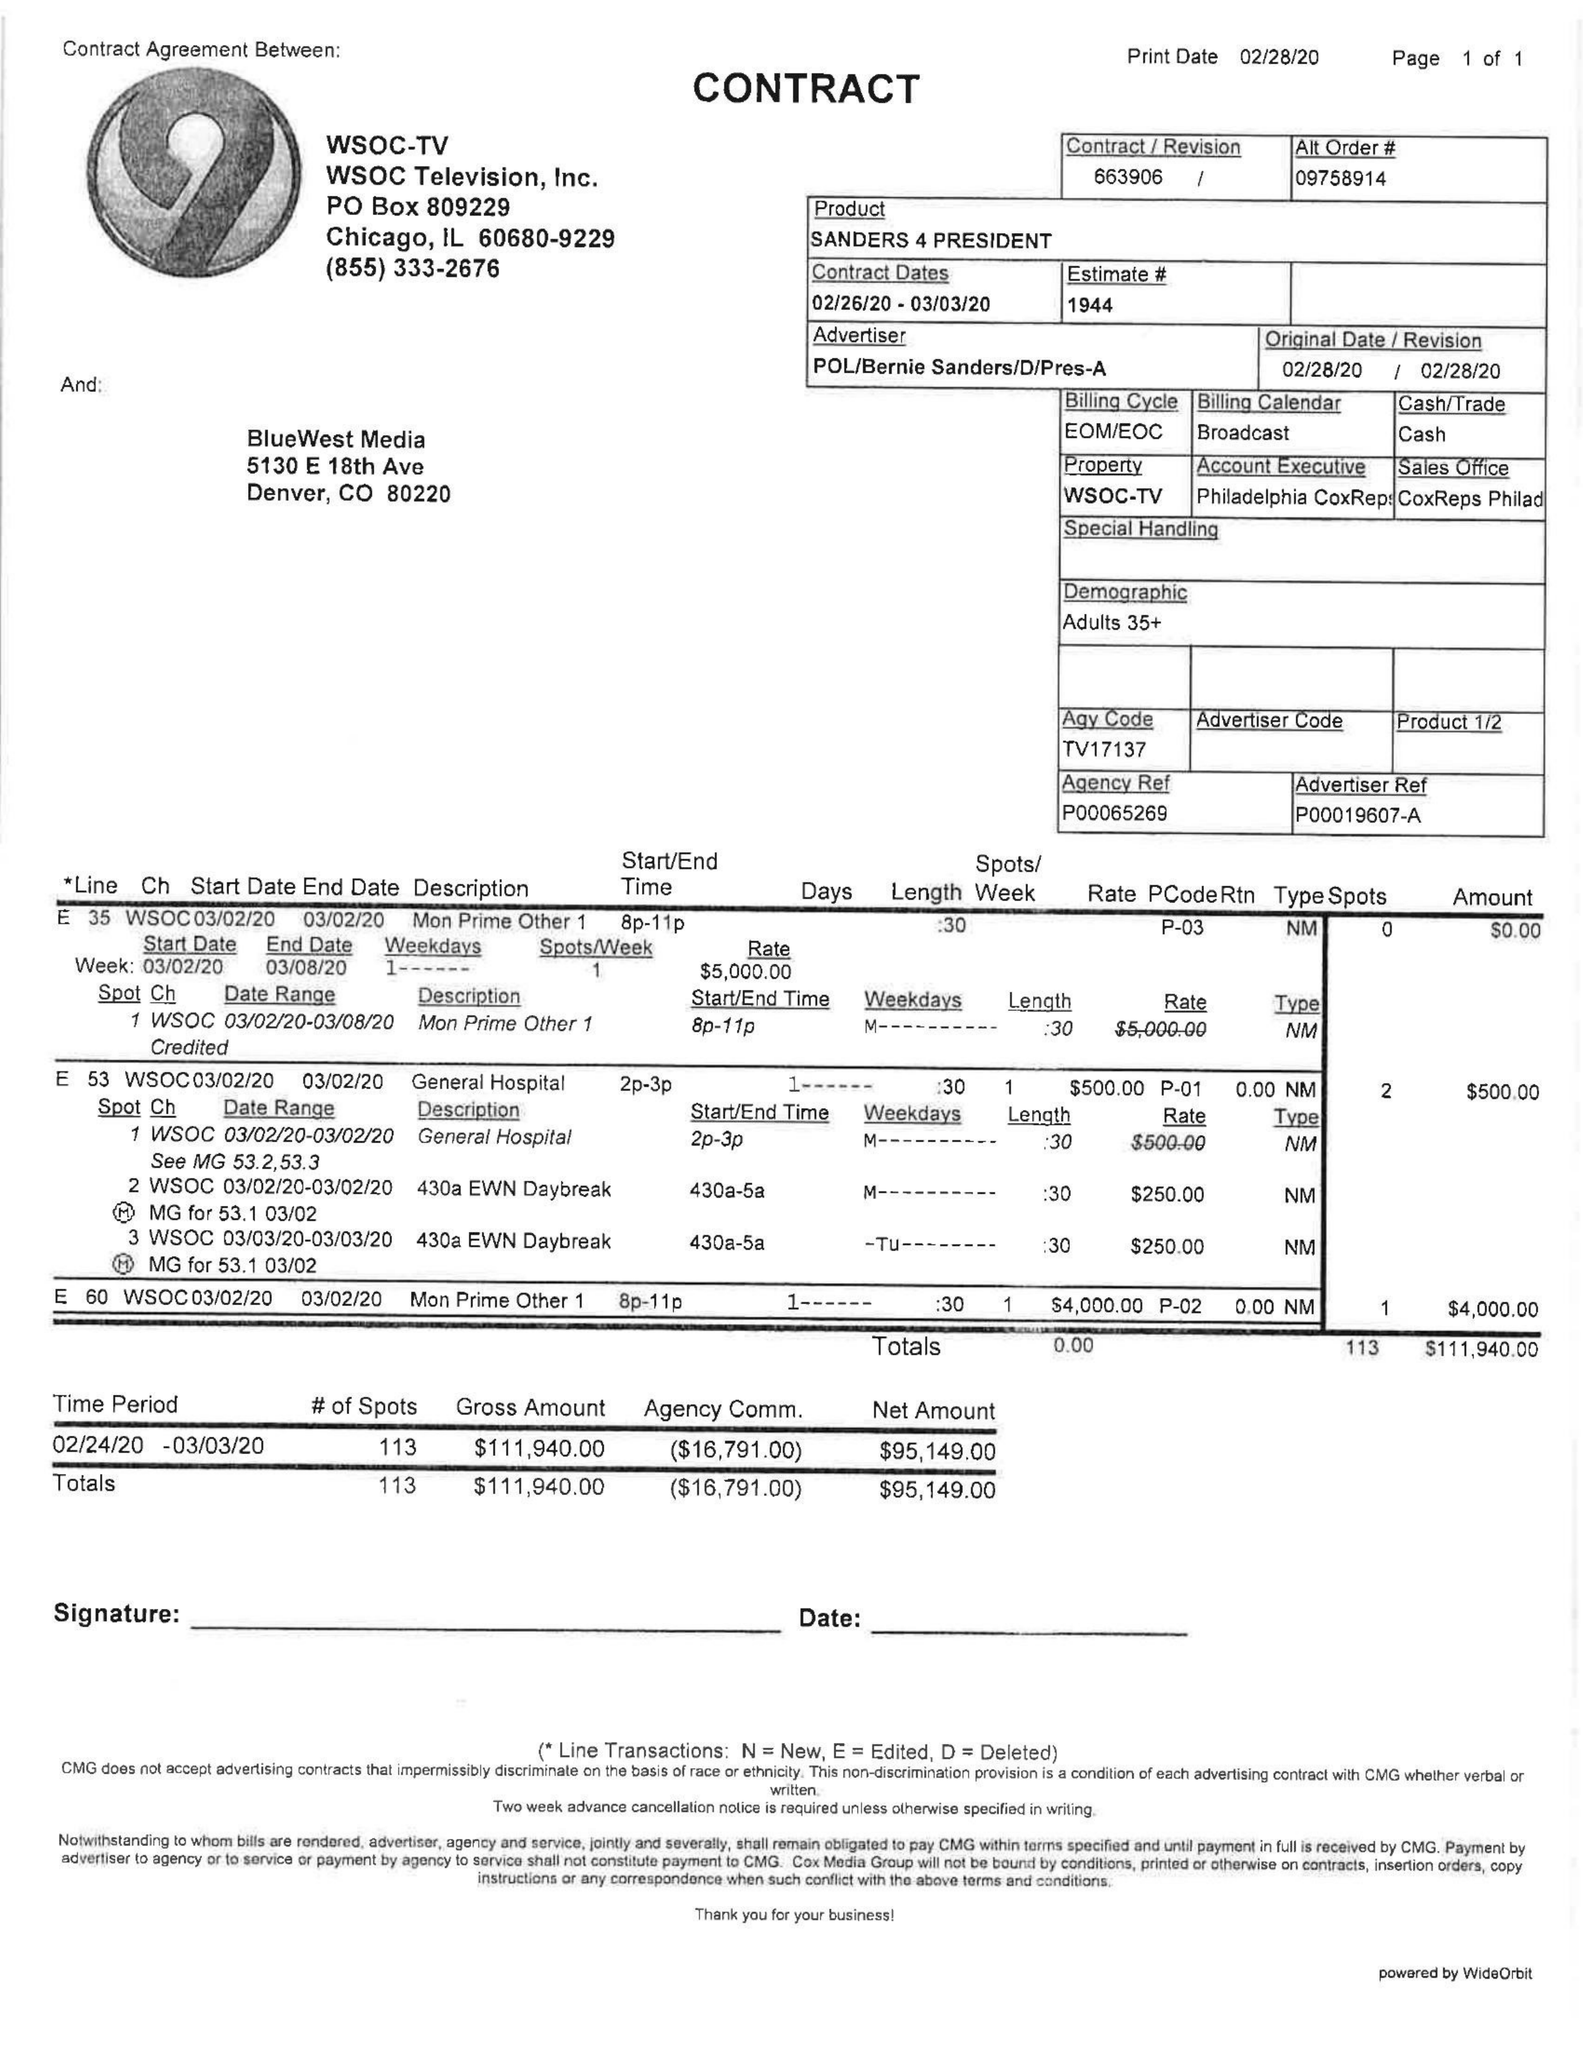What is the value for the gross_amount?
Answer the question using a single word or phrase. 111940.00 